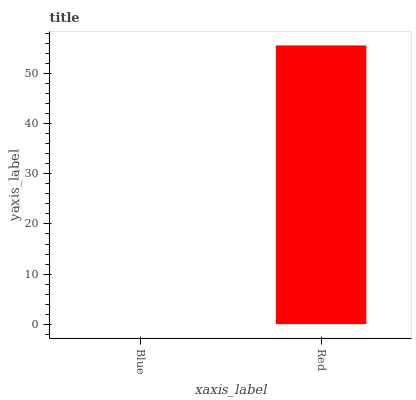Is Red the minimum?
Answer yes or no. No. Is Red greater than Blue?
Answer yes or no. Yes. Is Blue less than Red?
Answer yes or no. Yes. Is Blue greater than Red?
Answer yes or no. No. Is Red less than Blue?
Answer yes or no. No. Is Red the high median?
Answer yes or no. Yes. Is Blue the low median?
Answer yes or no. Yes. Is Blue the high median?
Answer yes or no. No. Is Red the low median?
Answer yes or no. No. 